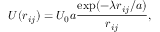<formula> <loc_0><loc_0><loc_500><loc_500>U ( r _ { i j } ) = U _ { 0 } a \frac { e x p ( - \lambda r _ { i j } / a ) } { r _ { i j } } ,</formula> 